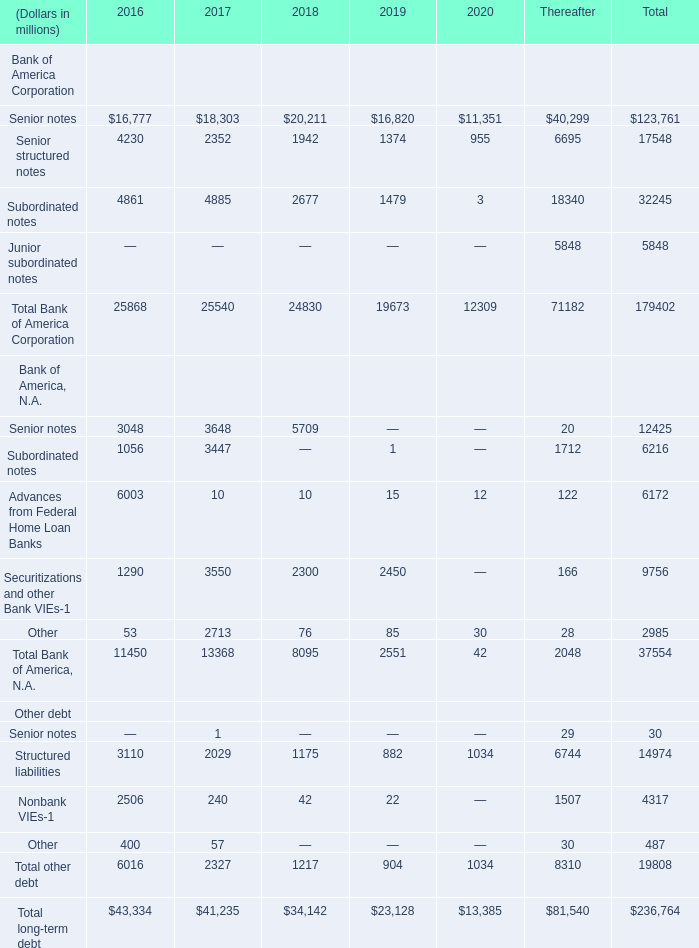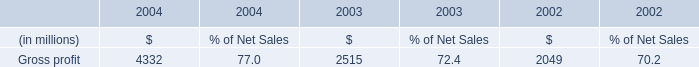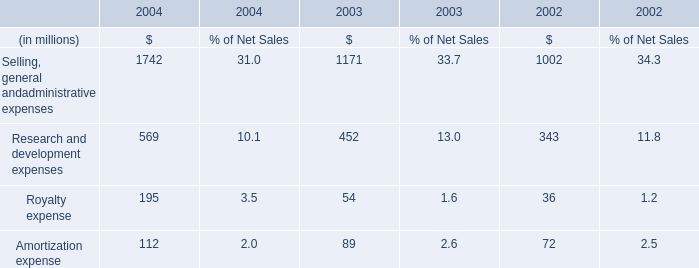Which year is Subordinated notes of Bank of America Corporation the most? 
Answer: 2017. 